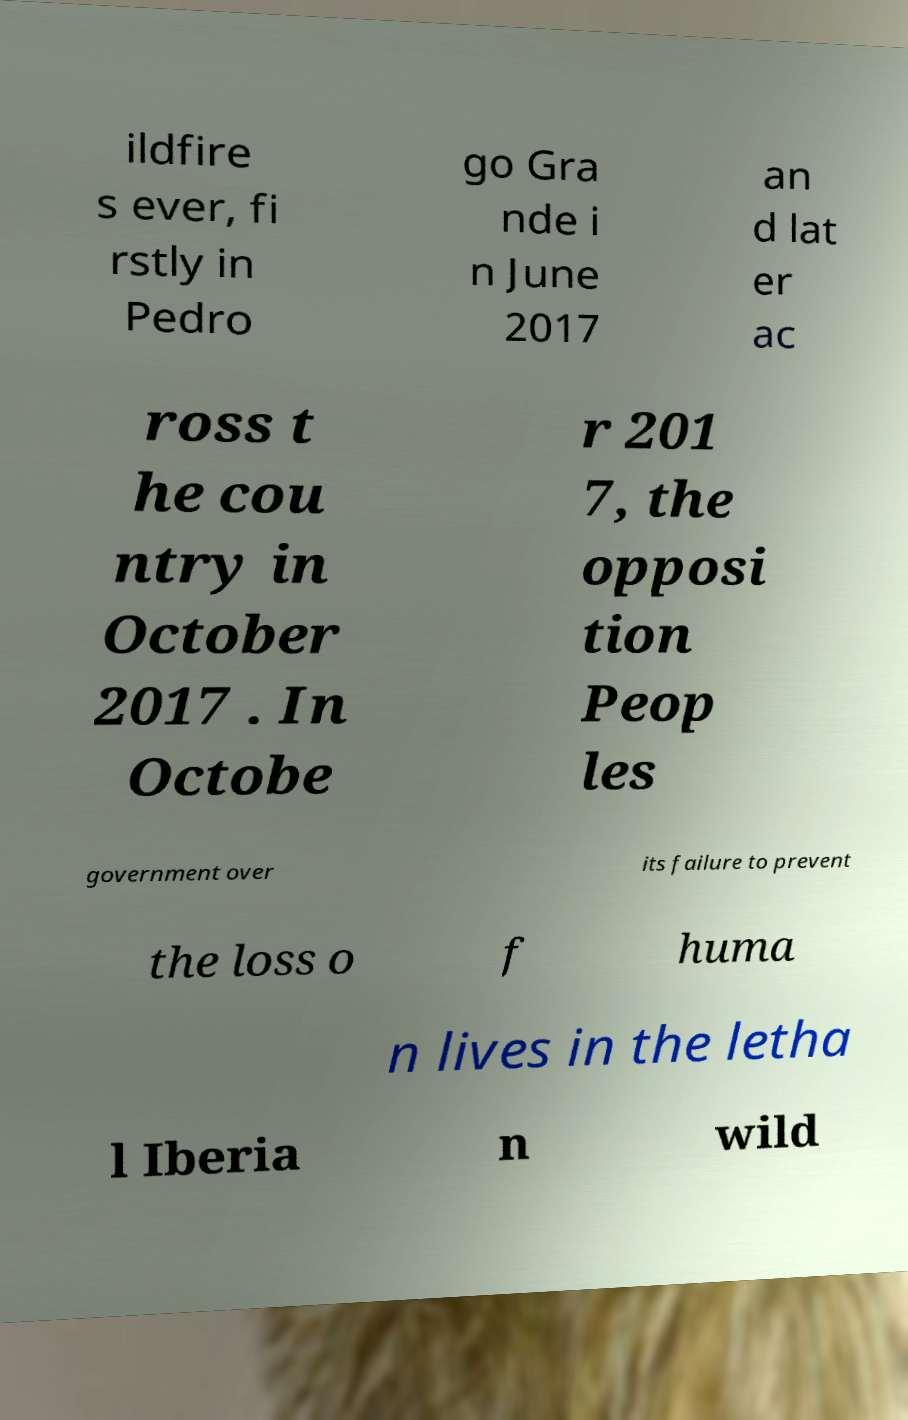I need the written content from this picture converted into text. Can you do that? ildfire s ever, fi rstly in Pedro go Gra nde i n June 2017 an d lat er ac ross t he cou ntry in October 2017 . In Octobe r 201 7, the opposi tion Peop les government over its failure to prevent the loss o f huma n lives in the letha l Iberia n wild 